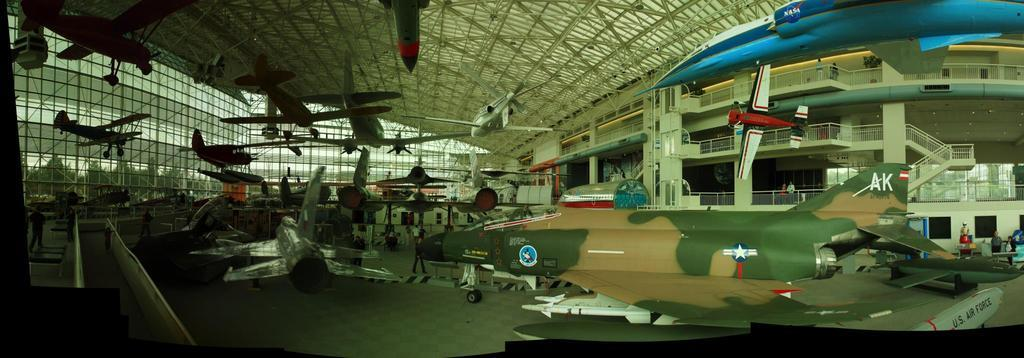What is the main subject of the image? The main subject of the image is aircrafts. Can you describe the people in the image? Yes, there are people in the image. What type of structure can be seen in the image? There is a fence in the image. What is visible on the ground in the image? The ground is visible in the image. Are there any architectural features in the image? Yes, there are stairs and a railing in the image. What is located at the top of the image? There is a shed at the top of the image. What type of suit is the expert wearing in the image? There is no expert or suit present in the image. What season is depicted in the image? The provided facts do not mention any specific season, so it cannot be determined from the image. 